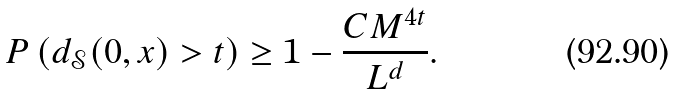Convert formula to latex. <formula><loc_0><loc_0><loc_500><loc_500>P \left ( d _ { \mathcal { S } } ( 0 , x ) > t \right ) \geq 1 - \frac { C M ^ { 4 t } } { L ^ { d } } .</formula> 